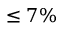Convert formula to latex. <formula><loc_0><loc_0><loc_500><loc_500>\leq 7 \%</formula> 